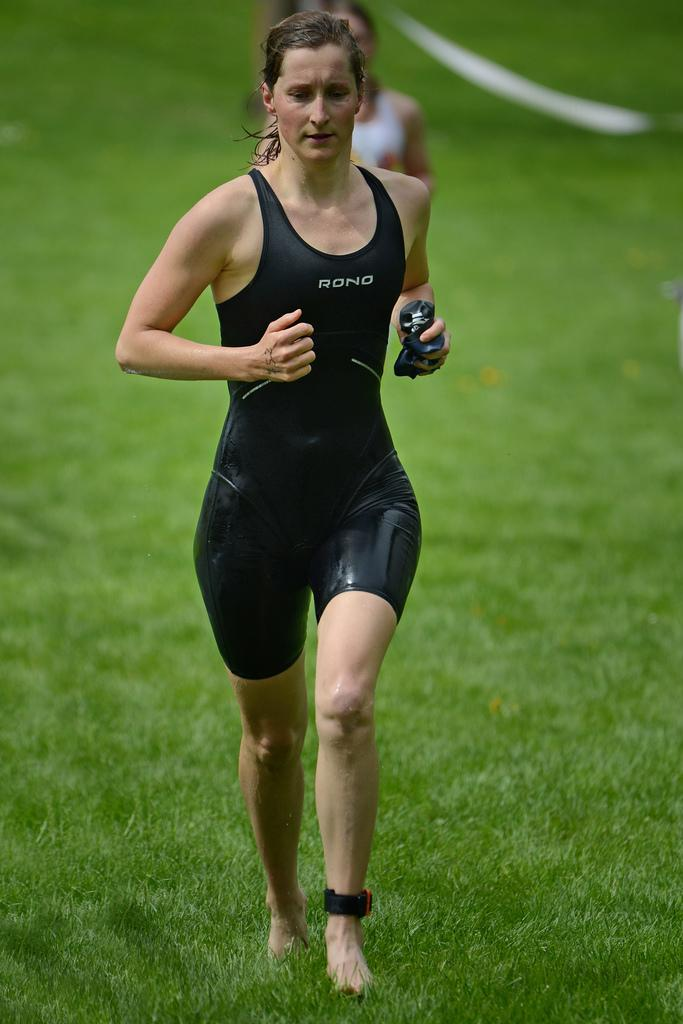What is the woman in the image wearing? The woman in the image is wearing a black t-shirt. What is the woman in the image doing? The woman is running. Can you describe the other woman in the image? The other woman in the image is wearing a white t-shirt. What type of surface is visible at the bottom of the image? The bottom of the image contains grass. What type of jam is the goat eating in the image? There is no goat or jam present in the image. Is the notebook visible in the image? There is no notebook present in the image. 